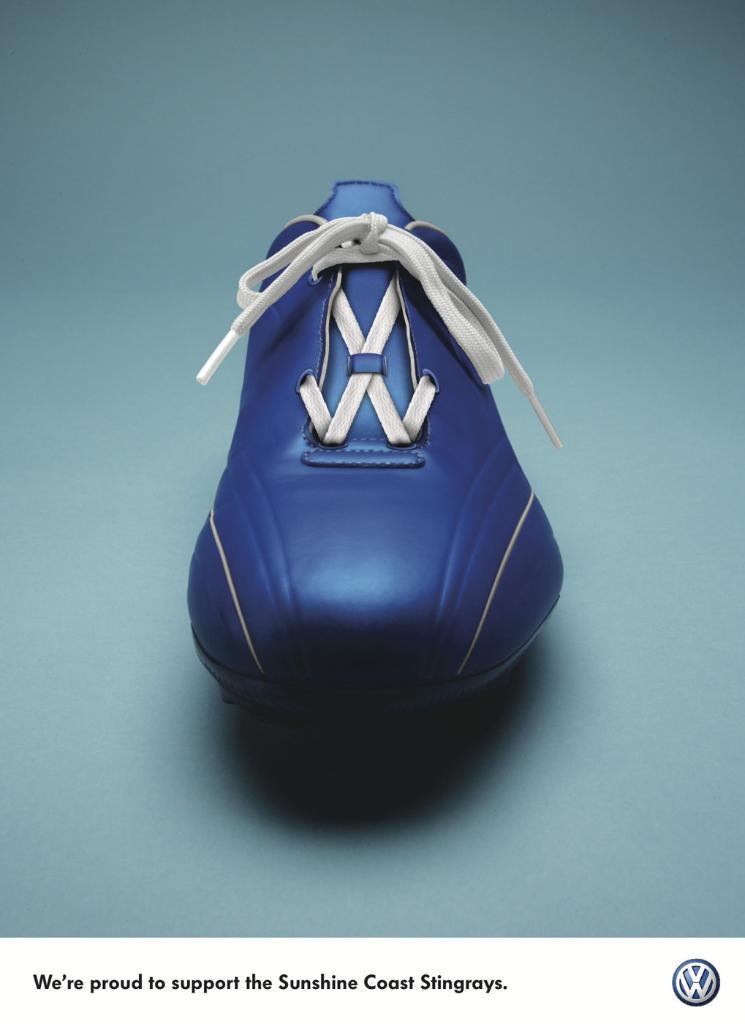Are they proud to support this team or not?
Offer a very short reply. Yes. 